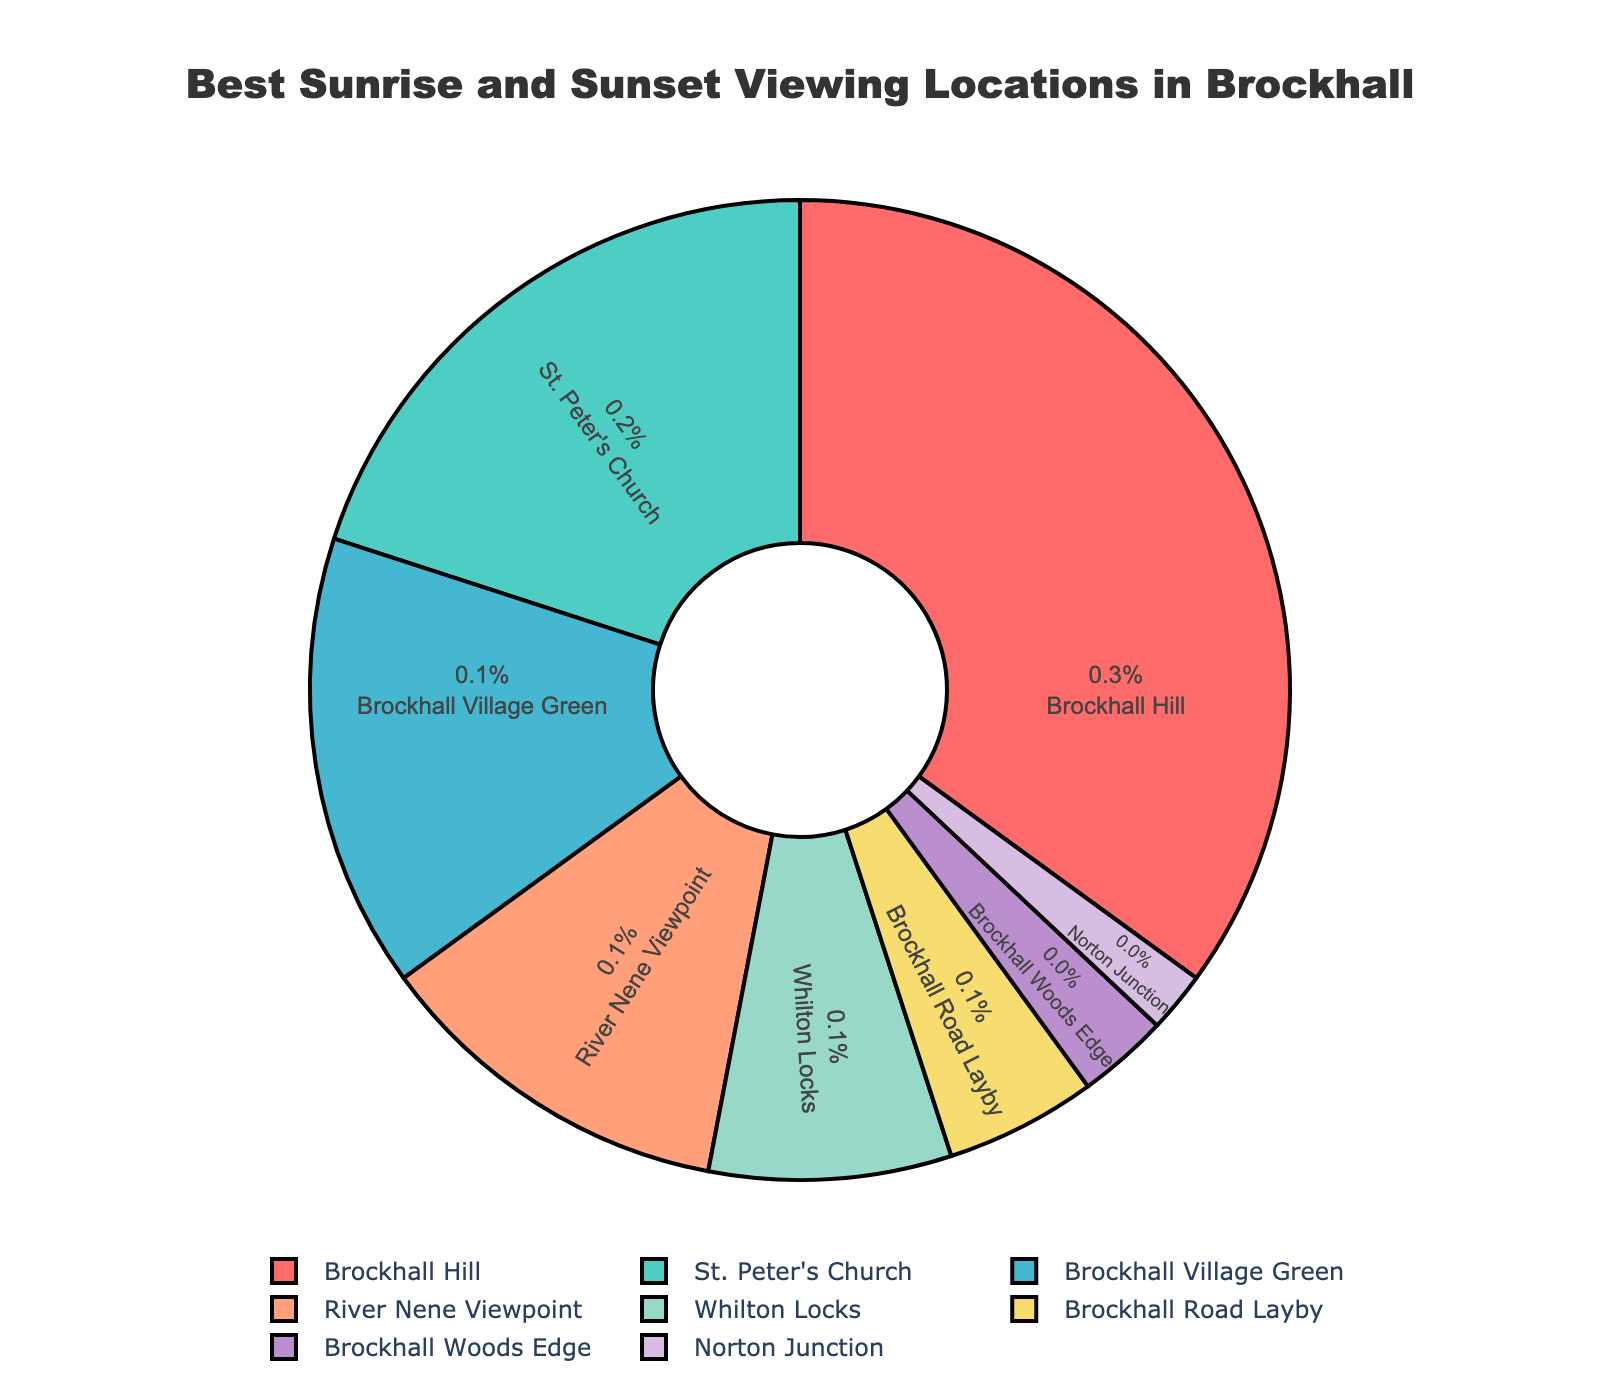What's the percentage of Brockhall Hill as a viewing location? Brockhall Hill's percentage is labeled directly in the pie chart.
Answer: 35% Which location has the smallest percentage of best viewing spots? By observing the pie chart, Norton Junction has the smallest percentage.
Answer: Norton Junction What is the combined percentage of St. Peter's Church and River Nene Viewpoint? Add the percentages of St. Peter's Church (20%) and River Nene Viewpoint (12%). 20 + 12 = 32.
Answer: 32% Is the percentage of Brockhall Village Green greater than Whilton Locks? Compare the percentages of both locations. Brockhall Village Green (15%) is indeed greater than Whilton Locks (8%).
Answer: Yes Which location is represented by the pink color? According to the visual color coding in the pie chart, Brockhall Hill is represented by pink.
Answer: Brockhall Hill How many locations have a percentage less than 10%? The locations with percentages less than 10 are Whilton Locks (8%), Brockhall Road Layby (5%), Brockhall Woods Edge (3%), and Norton Junction (2%). There are a total of 4 locations.
Answer: 4 Which two locations together make up 50% of the distribution? Combine percentages to find pairs summing to 50%. Brockhall Hill (35%) + St. Peter's Church (20%) = 55%. Brockhall Hill (35%) + Brockhall Village Green (15%) = 50%. Therefore, Brockhall Hill and Brockhall Village Green together make 50%.
Answer: Brockhall Hill and Brockhall Village Green What's the difference in percentage between the highest and lowest viewing locations? Subtract the smallest percentage (Norton Junction, 2%) from the largest percentage (Brockhall Hill, 35%). 35 - 2 = 33.
Answer: 33 If you combine Brockhall Village Green, River Nene Viewpoint, and Whilton Locks, what percentage do you get? Add the percentages: Brockhall Village Green (15%) + River Nene Viewpoint (12%) + Whilton Locks (8%) = 35. 15 + 12 + 8 = 35.
Answer: 35% What's the average percentage of all viewing locations listed? Sum all percentages and divide by the number of locations: (35 + 20 + 15 + 12 + 8 + 5 + 3 + 2) / 8 = 100 / 8 = 12.5.
Answer: 12.5 